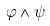<formula> <loc_0><loc_0><loc_500><loc_500>\varphi \wedge \psi</formula> 